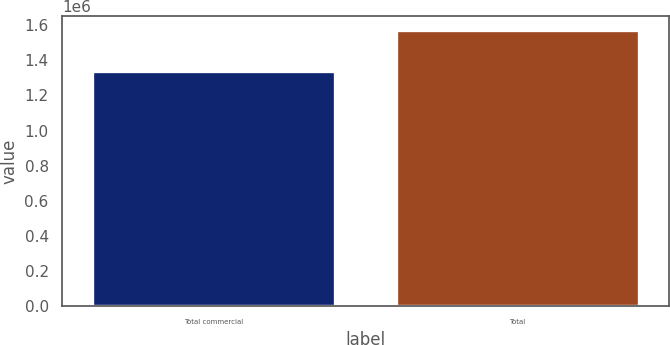Convert chart to OTSL. <chart><loc_0><loc_0><loc_500><loc_500><bar_chart><fcel>Total commercial<fcel>Total<nl><fcel>1.33928e+06<fcel>1.57242e+06<nl></chart> 